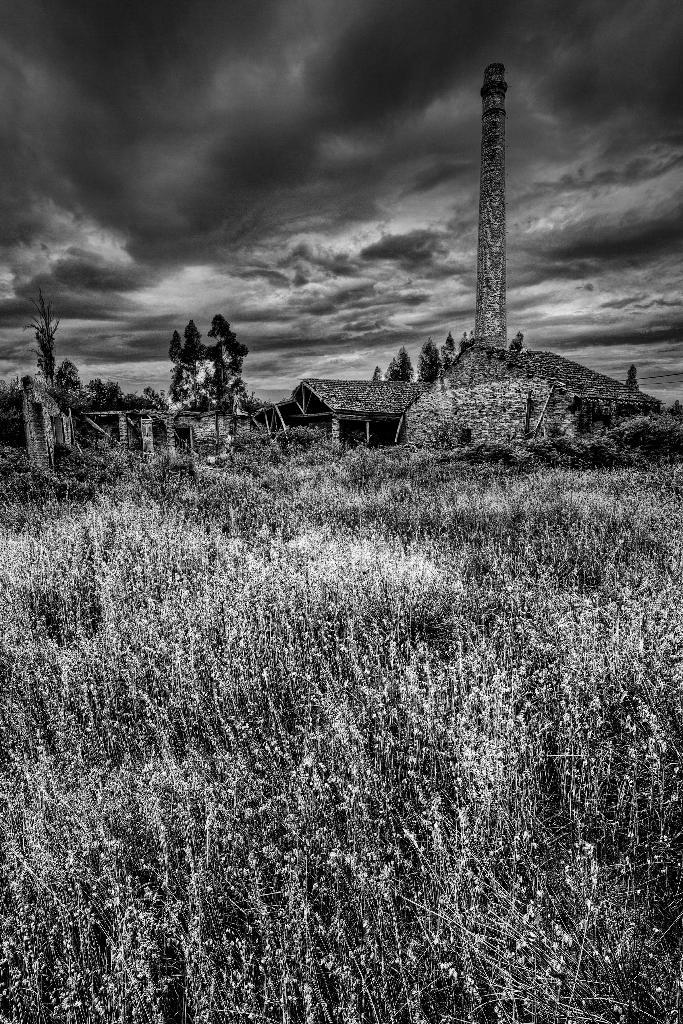What is the color scheme of the image? The image is black and white. What type of natural elements can be seen in the image? There are trees and plants in the image. What type of man-made structures are present in the image? There are houses and a tower in the image. What is visible in the background of the image? The sky is visible in the background of the image. How much wealth is represented by the stocking in the image? There is no stocking present in the image, and therefore no wealth can be associated with it. Is the image taken on an island? The provided facts do not mention anything about an island, so it cannot be determined from the image. 